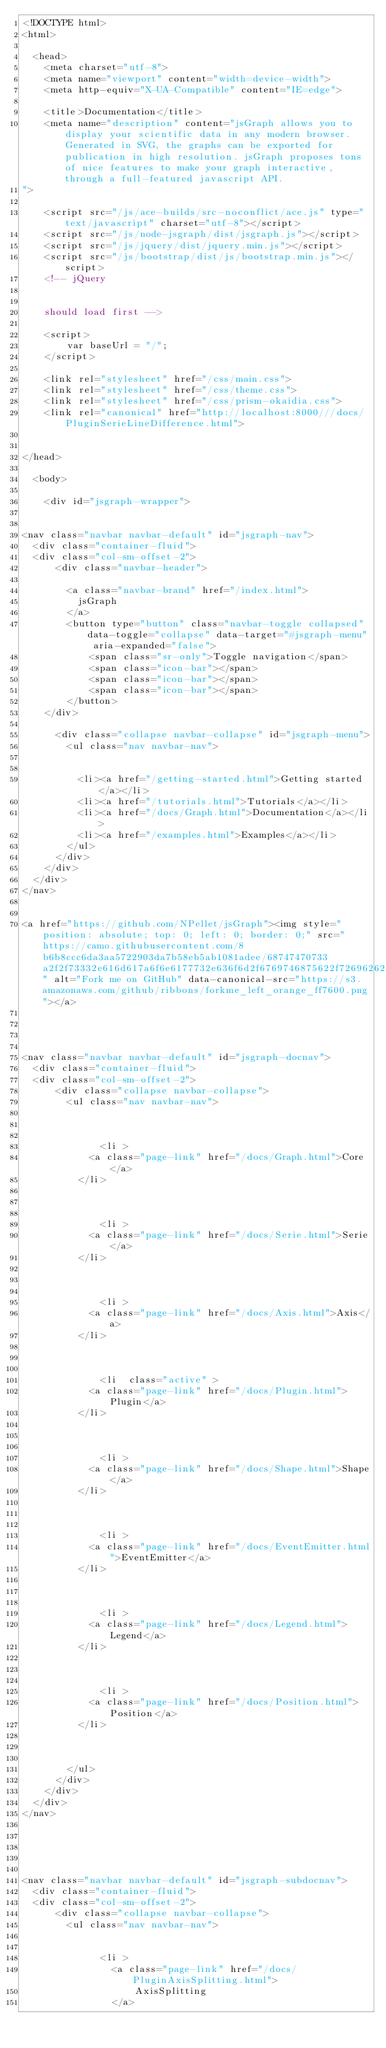Convert code to text. <code><loc_0><loc_0><loc_500><loc_500><_HTML_><!DOCTYPE html>
<html>

  <head>
    <meta charset="utf-8">
    <meta name="viewport" content="width=device-width">
    <meta http-equiv="X-UA-Compatible" content="IE=edge">

    <title>Documentation</title>
    <meta name="description" content="jsGraph allows you to display your scientific data in any modern browser.  Generated in SVG, the graphs can be exported for publication in high resolution. jsGraph proposes tons of nice features to make your graph interactive, through a full-featured javascript API.
">

    <script src="/js/ace-builds/src-noconflict/ace.js" type="text/javascript" charset="utf-8"></script>
    <script src="/js/node-jsgraph/dist/jsgraph.js"></script>
    <script src="/js/jquery/dist/jquery.min.js"></script>
    <script src="/js/bootstrap/dist/js/bootstrap.min.js"></script>
    <!-- jQuery 
    

    should load first -->

    <script>
        var baseUrl = "/";
    </script>

    <link rel="stylesheet" href="/css/main.css">
    <link rel="stylesheet" href="/css/theme.css">
    <link rel="stylesheet" href="/css/prism-okaidia.css">
    <link rel="canonical" href="http://localhost:8000///docs/PluginSerieLineDifference.html">


</head>

  <body>

  	<div id="jsgraph-wrapper">
	    

<nav class="navbar navbar-default" id="jsgraph-nav">
  <div class="container-fluid">
  <div class="col-sm-offset-2">
      <div class="navbar-header">

        <a class="navbar-brand" href="/index.html">
          jsGraph
        </a>
        <button type="button" class="navbar-toggle collapsed" data-toggle="collapse" data-target="#jsgraph-menu" aria-expanded="false">
            <span class="sr-only">Toggle navigation</span>
            <span class="icon-bar"></span>
            <span class="icon-bar"></span>
            <span class="icon-bar"></span>
        </button>
    </div>

      <div class="collapse navbar-collapse" id="jsgraph-menu">
        <ul class="nav navbar-nav">


          <li><a href="/getting-started.html">Getting started</a></li>
          <li><a href="/tutorials.html">Tutorials</a></li>
          <li><a href="/docs/Graph.html">Documentation</a></li>
          <li><a href="/examples.html">Examples</a></li>
        </ul>
      </div>
    </div>
  </div>
</nav>


<a href="https://github.com/NPellet/jsGraph"><img style="position: absolute; top: 0; left: 0; border: 0;" src="https://camo.githubusercontent.com/8b6b8ccc6da3aa5722903da7b58eb5ab1081adee/68747470733a2f2f73332e616d617a6f6e6177732e636f6d2f6769746875622f726962626f6e732f666f726b6d655f6c6566745f6f72616e67655f6666373630302e706e67" alt="Fork me on GitHub" data-canonical-src="https://s3.amazonaws.com/github/ribbons/forkme_left_orange_ff7600.png"></a>
	    
	    


<nav class="navbar navbar-default" id="jsgraph-docnav">
  <div class="container-fluid">
  <div class="col-sm-offset-2">
      <div class="collapse navbar-collapse">
        <ul class="nav navbar-nav">
            
  			
  			  
  			  <li >
            <a class="page-link" href="/docs/Graph.html">Core</a>
          </li>
  			  
  			
  			  
  			  <li >
            <a class="page-link" href="/docs/Serie.html">Serie</a>
          </li>
  			  
  			
  			  
  			  <li >
            <a class="page-link" href="/docs/Axis.html">Axis</a>
          </li>
  			  
  			
  			  
  			  <li  class="active" >
            <a class="page-link" href="/docs/Plugin.html">Plugin</a>
          </li>
  			  
  			
  			  
  			  <li >
            <a class="page-link" href="/docs/Shape.html">Shape</a>
          </li>
  			  
  			
  			  
  			  <li >
            <a class="page-link" href="/docs/EventEmitter.html">EventEmitter</a>
          </li>
  			  
  			
  			  
  			  <li >
            <a class="page-link" href="/docs/Legend.html">Legend</a>
          </li>
  			  
  			
  			  
  			  <li >
            <a class="page-link" href="/docs/Position.html">Position</a>
          </li>
  			  
  			

        </ul>
      </div>
    </div>
  </div>
</nav>





<nav class="navbar navbar-default" id="jsgraph-subdocnav">
  <div class="container-fluid">
  <div class="col-sm-offset-2">
      <div class="collapse navbar-collapse">
        <ul class="nav navbar-nav">
			
			  
			  <li >
			  	<a class="page-link" href="/docs/PluginAxisSplitting.html">
			  		AxisSplitting
			  	</a></code> 